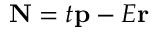<formula> <loc_0><loc_0><loc_500><loc_500>N = t p - E r</formula> 